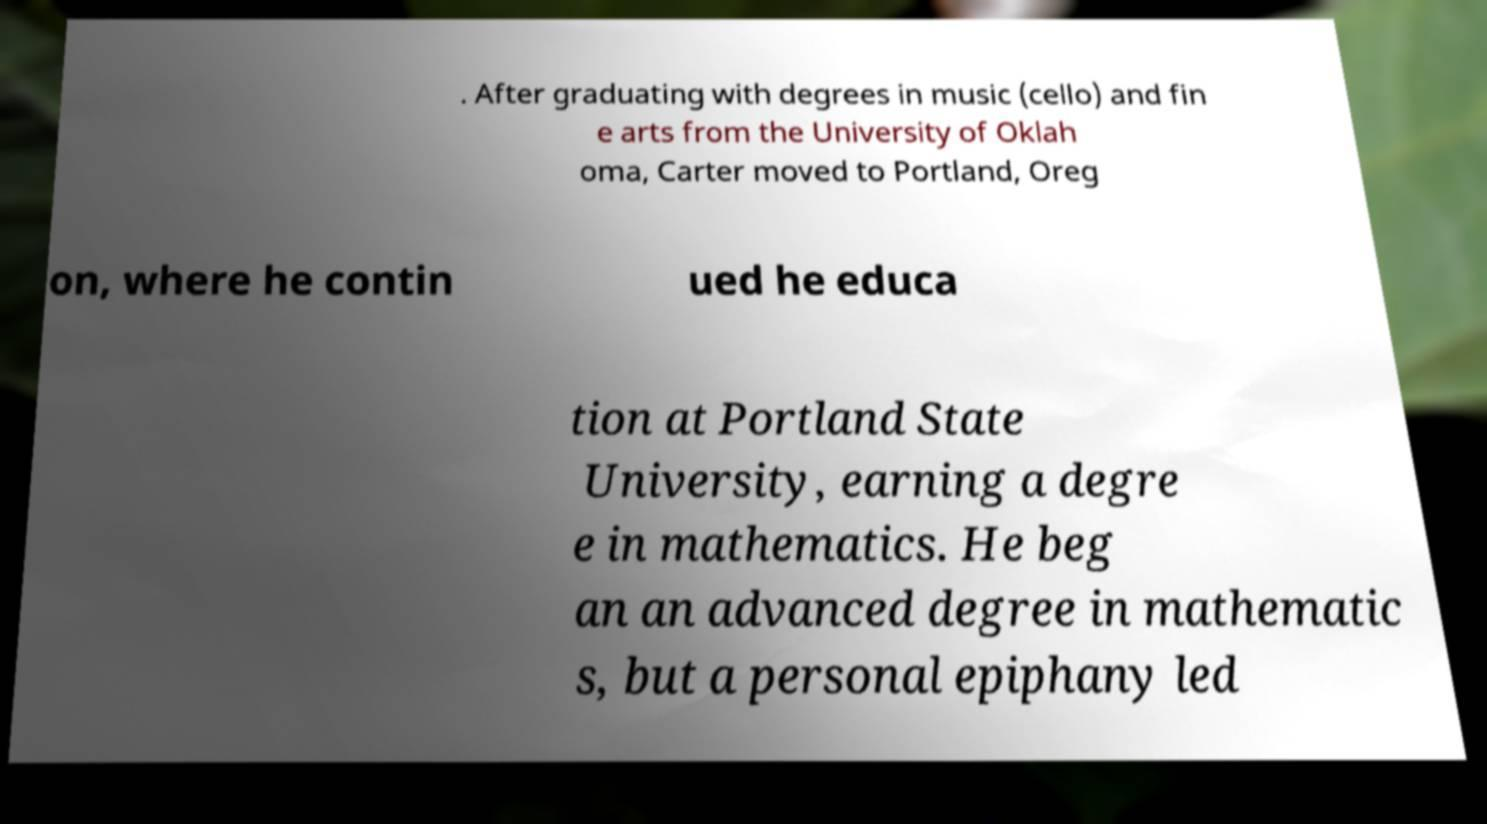I need the written content from this picture converted into text. Can you do that? . After graduating with degrees in music (cello) and fin e arts from the University of Oklah oma, Carter moved to Portland, Oreg on, where he contin ued he educa tion at Portland State University, earning a degre e in mathematics. He beg an an advanced degree in mathematic s, but a personal epiphany led 